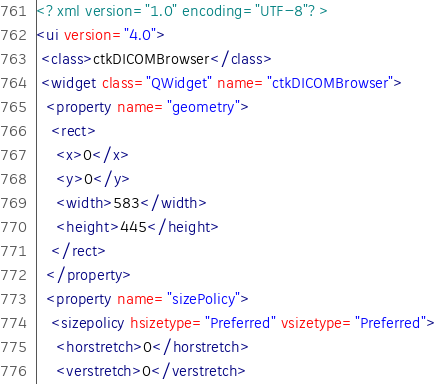Convert code to text. <code><loc_0><loc_0><loc_500><loc_500><_XML_><?xml version="1.0" encoding="UTF-8"?>
<ui version="4.0">
 <class>ctkDICOMBrowser</class>
 <widget class="QWidget" name="ctkDICOMBrowser">
  <property name="geometry">
   <rect>
    <x>0</x>
    <y>0</y>
    <width>583</width>
    <height>445</height>
   </rect>
  </property>
  <property name="sizePolicy">
   <sizepolicy hsizetype="Preferred" vsizetype="Preferred">
    <horstretch>0</horstretch>
    <verstretch>0</verstretch></code> 